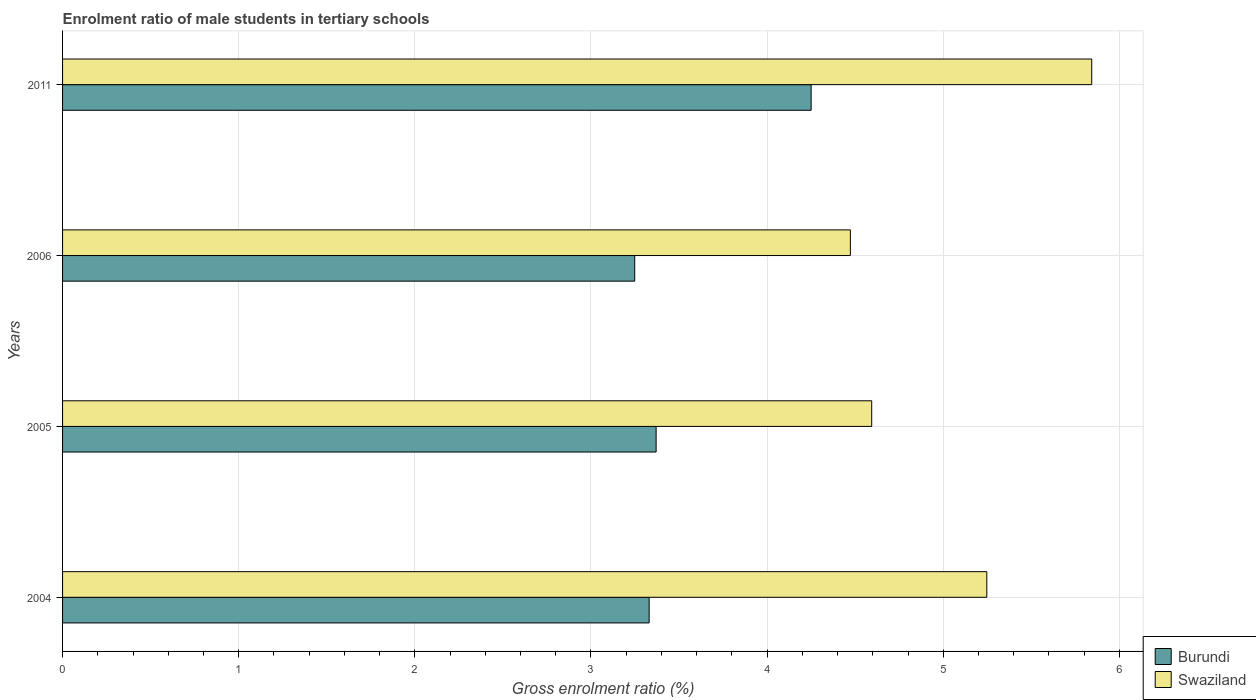How many different coloured bars are there?
Provide a succinct answer. 2. Are the number of bars per tick equal to the number of legend labels?
Ensure brevity in your answer.  Yes. Are the number of bars on each tick of the Y-axis equal?
Offer a very short reply. Yes. How many bars are there on the 2nd tick from the top?
Make the answer very short. 2. How many bars are there on the 2nd tick from the bottom?
Ensure brevity in your answer.  2. What is the label of the 2nd group of bars from the top?
Your answer should be compact. 2006. What is the enrolment ratio of male students in tertiary schools in Swaziland in 2006?
Give a very brief answer. 4.47. Across all years, what is the maximum enrolment ratio of male students in tertiary schools in Burundi?
Your response must be concise. 4.25. Across all years, what is the minimum enrolment ratio of male students in tertiary schools in Burundi?
Offer a terse response. 3.25. In which year was the enrolment ratio of male students in tertiary schools in Burundi maximum?
Provide a short and direct response. 2011. In which year was the enrolment ratio of male students in tertiary schools in Burundi minimum?
Your answer should be very brief. 2006. What is the total enrolment ratio of male students in tertiary schools in Burundi in the graph?
Provide a succinct answer. 14.2. What is the difference between the enrolment ratio of male students in tertiary schools in Burundi in 2004 and that in 2005?
Provide a short and direct response. -0.04. What is the difference between the enrolment ratio of male students in tertiary schools in Burundi in 2006 and the enrolment ratio of male students in tertiary schools in Swaziland in 2011?
Make the answer very short. -2.59. What is the average enrolment ratio of male students in tertiary schools in Burundi per year?
Offer a very short reply. 3.55. In the year 2006, what is the difference between the enrolment ratio of male students in tertiary schools in Swaziland and enrolment ratio of male students in tertiary schools in Burundi?
Keep it short and to the point. 1.22. In how many years, is the enrolment ratio of male students in tertiary schools in Burundi greater than 3 %?
Offer a terse response. 4. What is the ratio of the enrolment ratio of male students in tertiary schools in Swaziland in 2006 to that in 2011?
Offer a terse response. 0.77. Is the enrolment ratio of male students in tertiary schools in Burundi in 2005 less than that in 2006?
Your response must be concise. No. What is the difference between the highest and the second highest enrolment ratio of male students in tertiary schools in Burundi?
Provide a short and direct response. 0.88. What is the difference between the highest and the lowest enrolment ratio of male students in tertiary schools in Swaziland?
Provide a short and direct response. 1.37. Is the sum of the enrolment ratio of male students in tertiary schools in Swaziland in 2005 and 2011 greater than the maximum enrolment ratio of male students in tertiary schools in Burundi across all years?
Keep it short and to the point. Yes. What does the 1st bar from the top in 2006 represents?
Provide a short and direct response. Swaziland. What does the 1st bar from the bottom in 2004 represents?
Offer a very short reply. Burundi. Are all the bars in the graph horizontal?
Provide a short and direct response. Yes. How many years are there in the graph?
Offer a terse response. 4. Are the values on the major ticks of X-axis written in scientific E-notation?
Keep it short and to the point. No. Does the graph contain any zero values?
Make the answer very short. No. Where does the legend appear in the graph?
Your answer should be very brief. Bottom right. How many legend labels are there?
Your response must be concise. 2. What is the title of the graph?
Your answer should be compact. Enrolment ratio of male students in tertiary schools. What is the Gross enrolment ratio (%) in Burundi in 2004?
Offer a terse response. 3.33. What is the Gross enrolment ratio (%) in Swaziland in 2004?
Ensure brevity in your answer.  5.25. What is the Gross enrolment ratio (%) in Burundi in 2005?
Your answer should be very brief. 3.37. What is the Gross enrolment ratio (%) in Swaziland in 2005?
Your answer should be compact. 4.59. What is the Gross enrolment ratio (%) of Burundi in 2006?
Your answer should be very brief. 3.25. What is the Gross enrolment ratio (%) in Swaziland in 2006?
Provide a succinct answer. 4.47. What is the Gross enrolment ratio (%) in Burundi in 2011?
Keep it short and to the point. 4.25. What is the Gross enrolment ratio (%) in Swaziland in 2011?
Your answer should be very brief. 5.84. Across all years, what is the maximum Gross enrolment ratio (%) of Burundi?
Your answer should be compact. 4.25. Across all years, what is the maximum Gross enrolment ratio (%) in Swaziland?
Ensure brevity in your answer.  5.84. Across all years, what is the minimum Gross enrolment ratio (%) of Burundi?
Provide a succinct answer. 3.25. Across all years, what is the minimum Gross enrolment ratio (%) of Swaziland?
Your response must be concise. 4.47. What is the total Gross enrolment ratio (%) of Burundi in the graph?
Provide a succinct answer. 14.2. What is the total Gross enrolment ratio (%) in Swaziland in the graph?
Keep it short and to the point. 20.16. What is the difference between the Gross enrolment ratio (%) of Burundi in 2004 and that in 2005?
Offer a very short reply. -0.04. What is the difference between the Gross enrolment ratio (%) in Swaziland in 2004 and that in 2005?
Provide a short and direct response. 0.65. What is the difference between the Gross enrolment ratio (%) in Burundi in 2004 and that in 2006?
Provide a succinct answer. 0.08. What is the difference between the Gross enrolment ratio (%) in Swaziland in 2004 and that in 2006?
Ensure brevity in your answer.  0.77. What is the difference between the Gross enrolment ratio (%) of Burundi in 2004 and that in 2011?
Give a very brief answer. -0.92. What is the difference between the Gross enrolment ratio (%) of Swaziland in 2004 and that in 2011?
Make the answer very short. -0.6. What is the difference between the Gross enrolment ratio (%) of Burundi in 2005 and that in 2006?
Provide a short and direct response. 0.12. What is the difference between the Gross enrolment ratio (%) of Swaziland in 2005 and that in 2006?
Provide a short and direct response. 0.12. What is the difference between the Gross enrolment ratio (%) of Burundi in 2005 and that in 2011?
Your answer should be compact. -0.88. What is the difference between the Gross enrolment ratio (%) of Swaziland in 2005 and that in 2011?
Offer a very short reply. -1.25. What is the difference between the Gross enrolment ratio (%) in Burundi in 2006 and that in 2011?
Ensure brevity in your answer.  -1. What is the difference between the Gross enrolment ratio (%) of Swaziland in 2006 and that in 2011?
Offer a terse response. -1.37. What is the difference between the Gross enrolment ratio (%) of Burundi in 2004 and the Gross enrolment ratio (%) of Swaziland in 2005?
Give a very brief answer. -1.26. What is the difference between the Gross enrolment ratio (%) in Burundi in 2004 and the Gross enrolment ratio (%) in Swaziland in 2006?
Your response must be concise. -1.14. What is the difference between the Gross enrolment ratio (%) in Burundi in 2004 and the Gross enrolment ratio (%) in Swaziland in 2011?
Offer a very short reply. -2.51. What is the difference between the Gross enrolment ratio (%) of Burundi in 2005 and the Gross enrolment ratio (%) of Swaziland in 2006?
Offer a terse response. -1.1. What is the difference between the Gross enrolment ratio (%) of Burundi in 2005 and the Gross enrolment ratio (%) of Swaziland in 2011?
Make the answer very short. -2.47. What is the difference between the Gross enrolment ratio (%) in Burundi in 2006 and the Gross enrolment ratio (%) in Swaziland in 2011?
Your answer should be very brief. -2.59. What is the average Gross enrolment ratio (%) in Burundi per year?
Ensure brevity in your answer.  3.55. What is the average Gross enrolment ratio (%) in Swaziland per year?
Give a very brief answer. 5.04. In the year 2004, what is the difference between the Gross enrolment ratio (%) of Burundi and Gross enrolment ratio (%) of Swaziland?
Ensure brevity in your answer.  -1.92. In the year 2005, what is the difference between the Gross enrolment ratio (%) in Burundi and Gross enrolment ratio (%) in Swaziland?
Your response must be concise. -1.22. In the year 2006, what is the difference between the Gross enrolment ratio (%) of Burundi and Gross enrolment ratio (%) of Swaziland?
Keep it short and to the point. -1.22. In the year 2011, what is the difference between the Gross enrolment ratio (%) in Burundi and Gross enrolment ratio (%) in Swaziland?
Keep it short and to the point. -1.59. What is the ratio of the Gross enrolment ratio (%) of Burundi in 2004 to that in 2005?
Your answer should be compact. 0.99. What is the ratio of the Gross enrolment ratio (%) in Swaziland in 2004 to that in 2005?
Provide a short and direct response. 1.14. What is the ratio of the Gross enrolment ratio (%) in Burundi in 2004 to that in 2006?
Offer a terse response. 1.03. What is the ratio of the Gross enrolment ratio (%) of Swaziland in 2004 to that in 2006?
Ensure brevity in your answer.  1.17. What is the ratio of the Gross enrolment ratio (%) in Burundi in 2004 to that in 2011?
Offer a terse response. 0.78. What is the ratio of the Gross enrolment ratio (%) of Swaziland in 2004 to that in 2011?
Ensure brevity in your answer.  0.9. What is the ratio of the Gross enrolment ratio (%) of Burundi in 2005 to that in 2006?
Provide a short and direct response. 1.04. What is the ratio of the Gross enrolment ratio (%) in Swaziland in 2005 to that in 2006?
Provide a short and direct response. 1.03. What is the ratio of the Gross enrolment ratio (%) in Burundi in 2005 to that in 2011?
Give a very brief answer. 0.79. What is the ratio of the Gross enrolment ratio (%) of Swaziland in 2005 to that in 2011?
Provide a short and direct response. 0.79. What is the ratio of the Gross enrolment ratio (%) in Burundi in 2006 to that in 2011?
Provide a short and direct response. 0.76. What is the ratio of the Gross enrolment ratio (%) of Swaziland in 2006 to that in 2011?
Offer a terse response. 0.77. What is the difference between the highest and the second highest Gross enrolment ratio (%) of Burundi?
Offer a very short reply. 0.88. What is the difference between the highest and the second highest Gross enrolment ratio (%) of Swaziland?
Offer a terse response. 0.6. What is the difference between the highest and the lowest Gross enrolment ratio (%) of Burundi?
Ensure brevity in your answer.  1. What is the difference between the highest and the lowest Gross enrolment ratio (%) of Swaziland?
Make the answer very short. 1.37. 